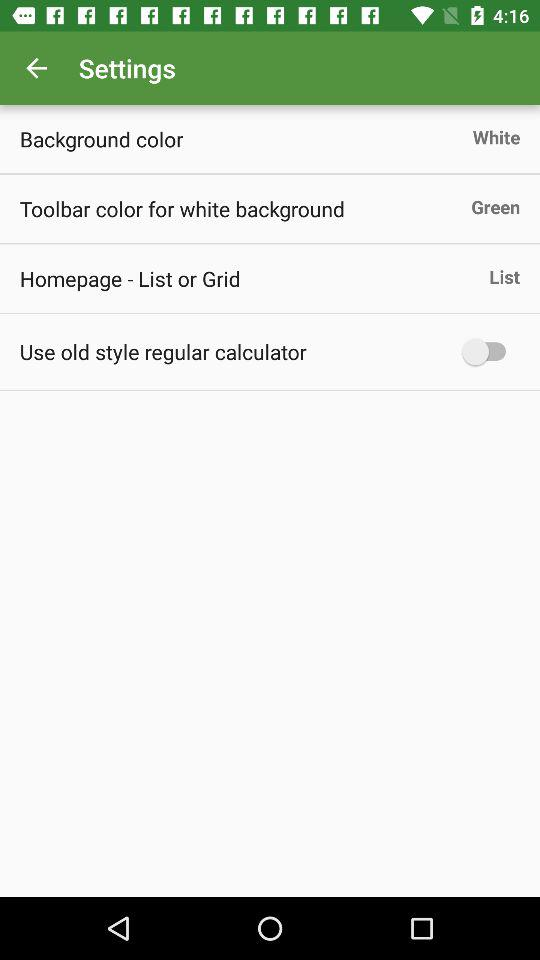What is the setting for homepage? The setting for homepage is "List". 